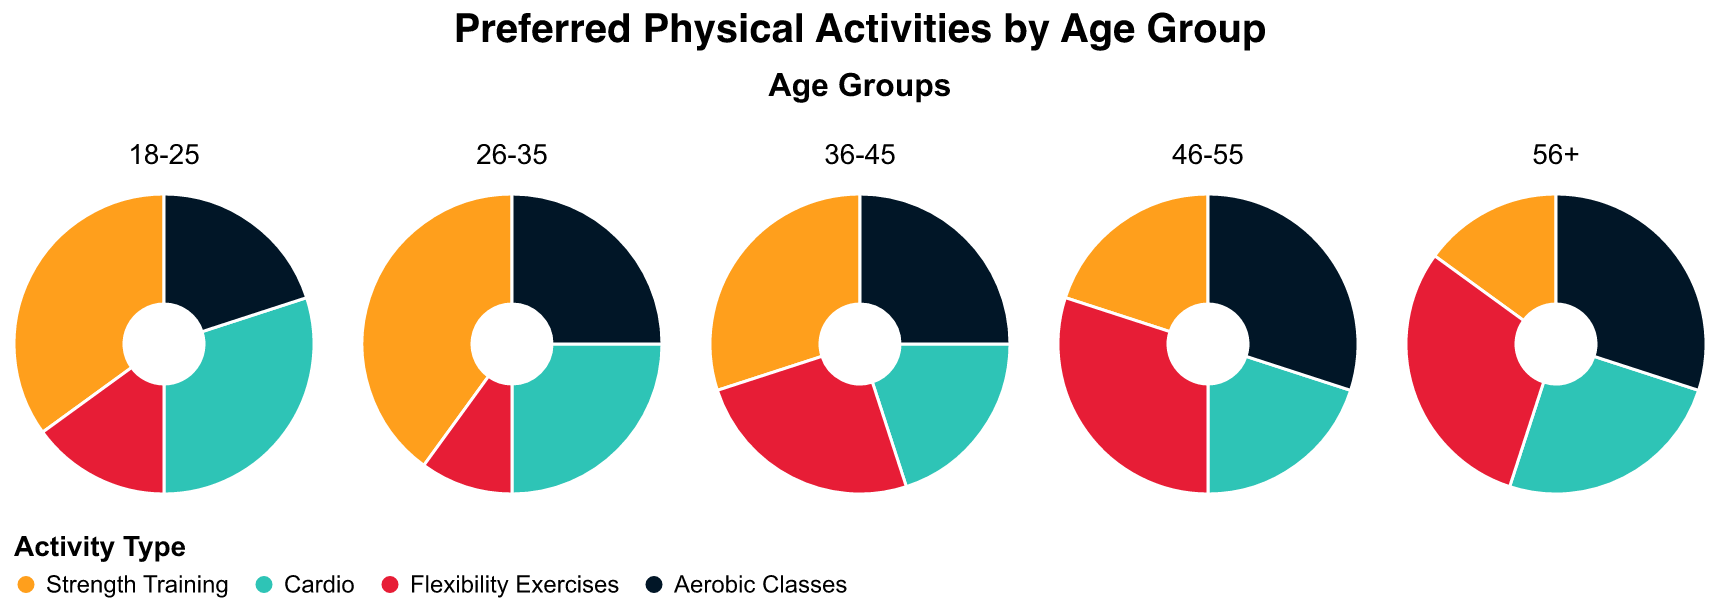What's the most preferred activity for the 18-25 age group? Looking at the 18-25 age group's subplot, the largest segment is for Strength Training at 35%.
Answer: Strength Training Which age group has the highest proportion for Flexibility Exercises? For each age group, I will locate the segment for Flexibility Exercises and compare their proportions. The 56+ and 46-55 age groups both have the highest proportion of 30% for Flexibility Exercises.
Answer: 56+ and 46-55 How does the proportion of Cardio for the 26-35 age group compare to the 36-45 age group? The subplot for the 26-35 age group shows a 25% proportion for Cardio. In comparison, the 36-45 age group subplot displays 20% for Cardio. Therefore, the 26-35 age group prefers Cardio more than the 36-45 age group by 5%.
Answer: 5% higher Which age group prefers Aerobic Classes equally? By examining the proportions for Aerobic Classes, the 36-45, 46-55, and 56+ age groups all show an equal proportion of 30%.
Answer: 36-45, 46-55, and 56+ What is the sum of the proportions for all activities in the 18-25 age group? The proportions for the 18-25 age group are 35%, 30%, 15%, and 20%. Adding these gives us 35 + 30 + 15 + 20 = 100%.
Answer: 100% Which age group has the least preference for Strength Training? Observing each age group's subplot, the 56+ age group has the smallest proportion for Strength Training at 15%.
Answer: 56+ What's the difference in proportion between Flexibility Exercises and Aerobic Classes for the 46-55 age group? For the 46-55 age group subplot, the proportion for Flexibility Exercises is 30% and for Aerobic Classes is also 30%. Therefore, the difference is 0%.
Answer: 0% What activity has the smallest proportion among the 26-35 age group? Checking the 26-35 age group's subplot, the smallest segment is Flexibility Exercises at 10%.
Answer: Flexibility Exercises 